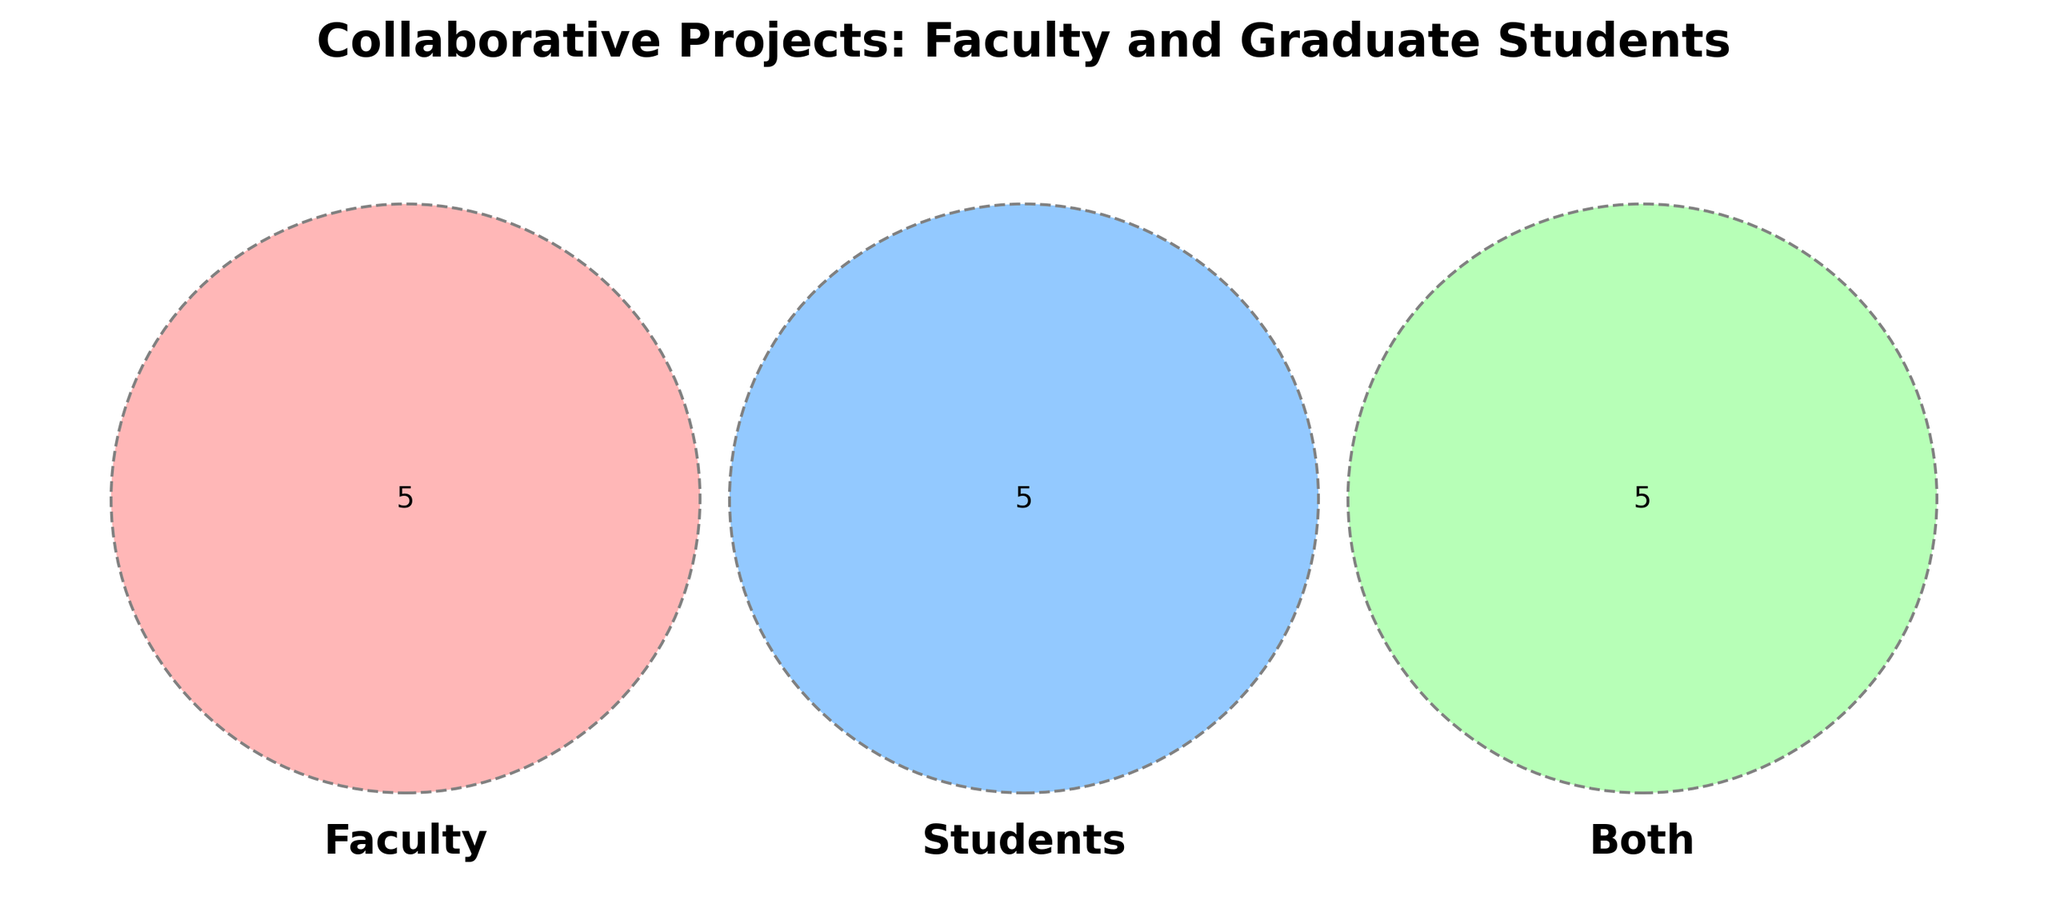What's the title of the figure? The title is located at the top of the Venn diagram and is designed to give a quick understanding of the figure's context. The title reads "Collaborative Projects: Faculty and Graduate Students."
Answer: Collaborative Projects: Faculty and Graduate Students What color represents the 'Both' category in the Venn diagram? In the Venn diagram, different categories are represented by unique colors. The 'Both' category is represented by a light green color.
Answer: Light green How many items are there in the 'Faculty' category alone? The Venn diagram visually separates the items into different sections. By looking at the section that represents 'Faculty' alone, there are five items: Quantum optics, Grant writing, Curriculum development, Department meetings, and Equipment procurement.
Answer: 5 How many items are shared between 'Students' and 'Both' but not with 'Faculty'? To find items shared between 'Students' and 'Both' but not with 'Faculty', we focus on the intersection of 'Students' and 'Both' without including 'Faculty'. There are no such items because the 'Both' category inherently includes items from 'Faculty' and 'Students'.
Answer: 0 Which category contains "Funding proposals"? "Funding proposals" can be found in the section of the Venn diagram where all three sets (Faculty, Students, Both) intersect, indicating it is a collaborative effort involving both faculty and students.
Answer: Both What activity is common to both faculty and students but not exclusive to either group? The Venn diagram indicates that "Journal club discussions" is located in the 'Both' section, showing that this activity is a collaborative effort rather than exclusive to faculty or students.
Answer: Journal club discussions How many items are shared across all three categories (Faculty, Students, Both)? The section at the center of the Venn diagram where all three circles intersect tells us the shared items. There are three items shared across all categories: Research publications, Conference presentations, and Experiment design.
Answer: 3 Which category has more unique activities, Faculty or Students? By counting the unique activities in each category, Faculty has five unique activities, and Students have five unique activities as well. Both have an equal number of unique activities.
Answer: Equal What collaborative activities are listed under 'Both' relating to academic work? Several activities under the 'Both' section relate to academic work, such as "Research publications," "Conference presentations," "Experiment design," and "Funding proposals." This involves a deeper analysis of the nature of the collaborative activities listed.
Answer: 4 